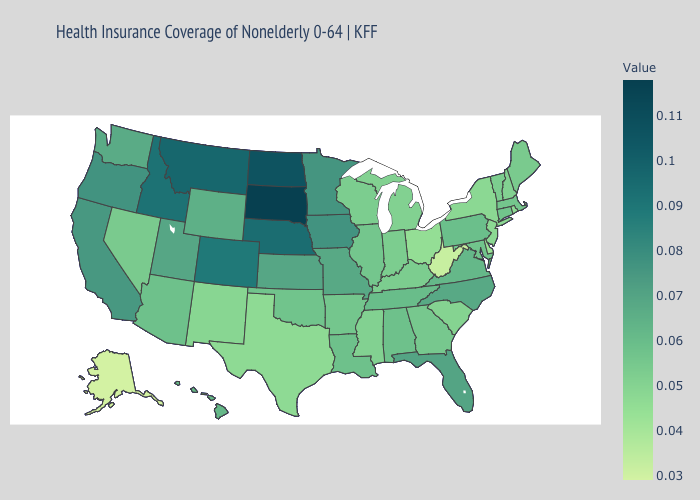Which states have the lowest value in the Northeast?
Concise answer only. Rhode Island. Among the states that border Nevada , which have the lowest value?
Quick response, please. Arizona. Among the states that border California , which have the lowest value?
Give a very brief answer. Nevada. Does Rhode Island have the lowest value in the USA?
Be succinct. No. Among the states that border Massachusetts , does Vermont have the lowest value?
Give a very brief answer. No. 